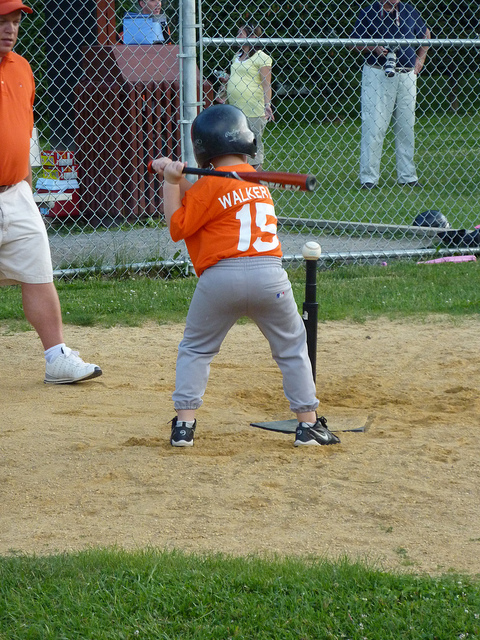Please transcribe the text information in this image. WALKER 15 